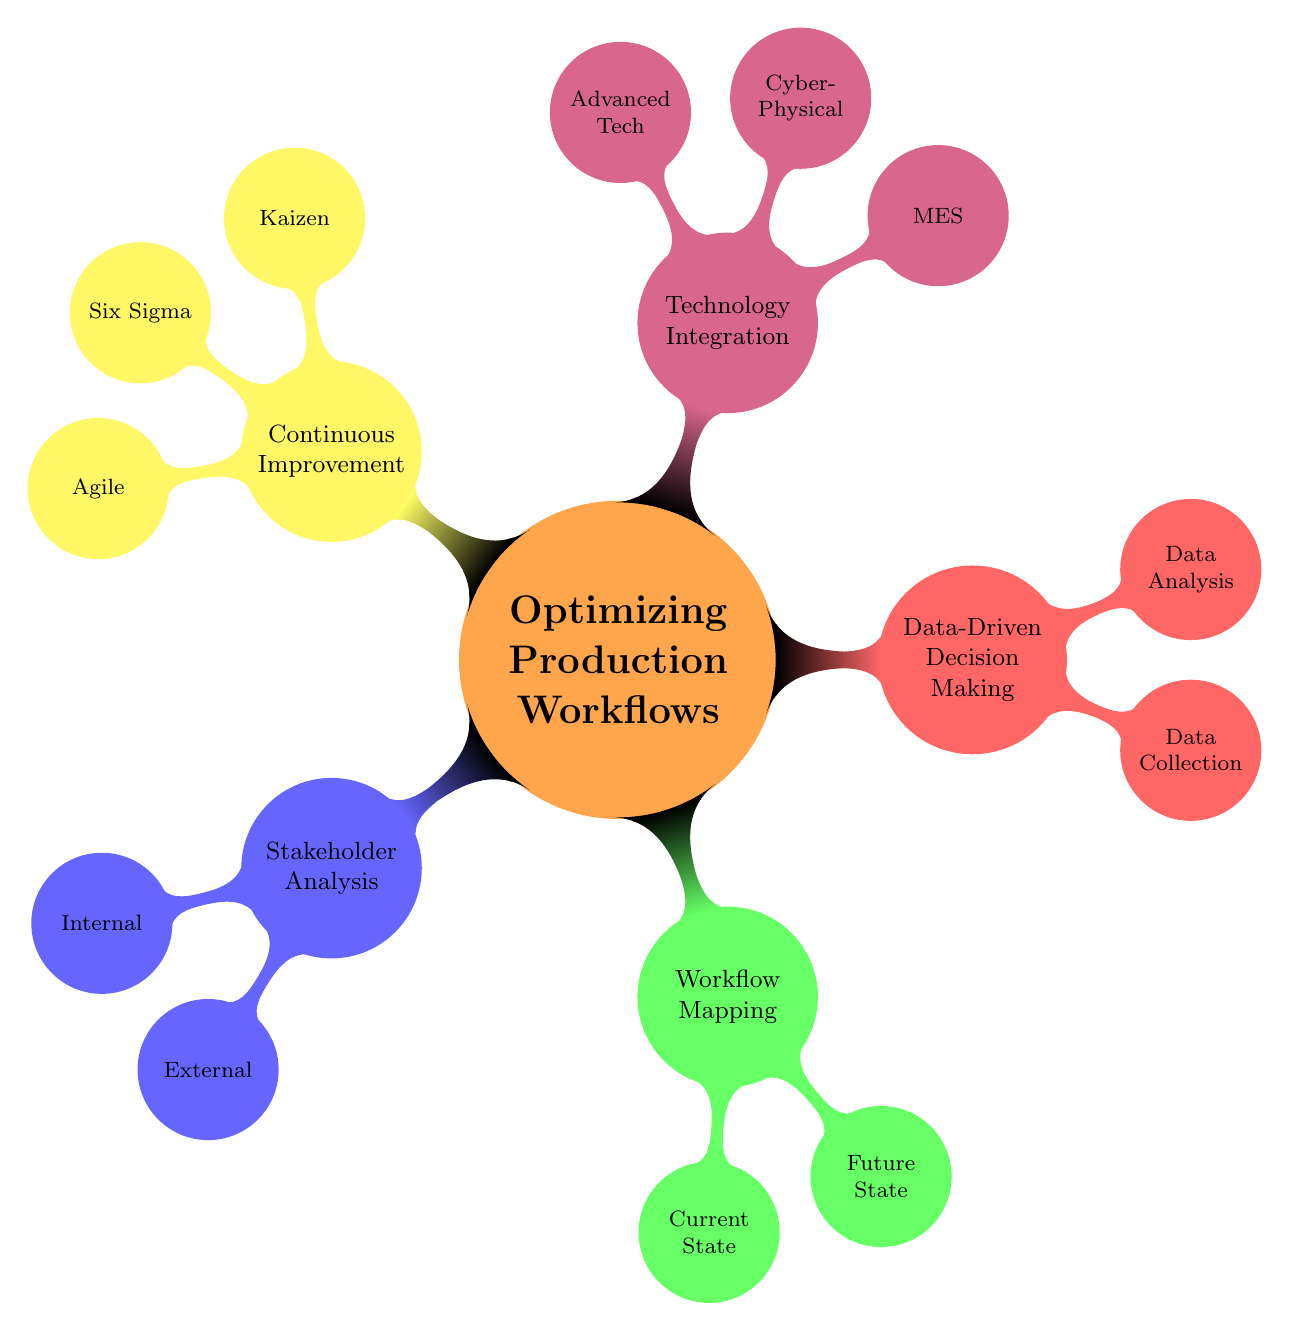What is the main subject of the diagram? The diagram focuses on the central theme, which is clearly labeled as "Optimizing Production Workflows Through Systems Engineering.”
Answer: Optimizing Production Workflows Through Systems Engineering How many main branches are there in the mind map? The diagram has five main branches emanating from the central node. These branches represent key areas: Stakeholder Analysis, Workflow Mapping, Data-Driven Decision Making, Technology Integration, and Continuous Improvement.
Answer: 5 What are the two categories of stakeholders listed in the diagram? Under the Stakeholder Analysis node, the diagram identifies two specific categories: Internal Stakeholders and External Stakeholders.
Answer: Internal Stakeholders and External Stakeholders Name one area addressed in Current State Analysis under Workflow Mapping. Within the Workflow Mapping section, one area that is addressed under Current State Analysis is Bottleneck Identification.
Answer: Bottleneck Identification Which methodology is categorized under Continuous Improvement? The diagram lists several methodologies under Continuous Improvement, and one of them is Six Sigma.
Answer: Six Sigma How does Data Collection relate to Data Analysis in the diagram? The diagram shows that Data Collection and Data Analysis are two connected components under the Data-Driven Decision Making branch, indicating that effective data collection contributes to informed data analysis.
Answer: Data Collection contributes to Data Analysis What technology is associated with Real-Time Monitoring? Real-Time Monitoring is associated with the Manufacturing Execution Systems (MES) category under Technology Integration in the diagram.
Answer: Manufacturing Execution Systems (MES) Which concept is linked to Agile Practices within Continuous Improvement? Agile Practices is a concept listed under Continuous Improvement, which is part of a broader strategy for iterative processes and rapid development.
Answer: Agile Practices What color represents the Technology Integration branch in the diagram? Each branch in the mind map has a specific color, and Technology Integration is represented by purple.
Answer: Purple 